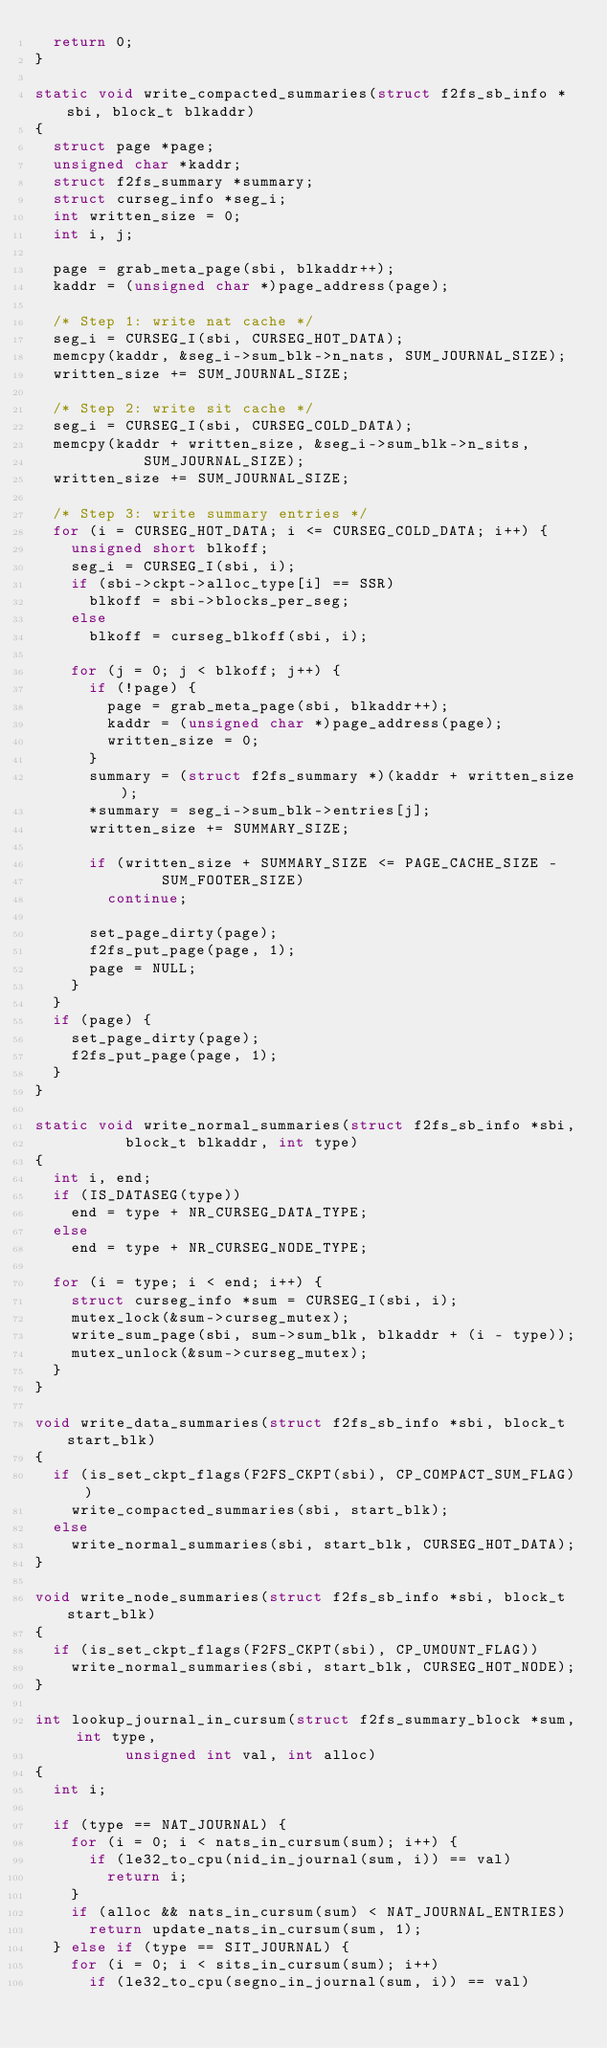<code> <loc_0><loc_0><loc_500><loc_500><_C_>	return 0;
}

static void write_compacted_summaries(struct f2fs_sb_info *sbi, block_t blkaddr)
{
	struct page *page;
	unsigned char *kaddr;
	struct f2fs_summary *summary;
	struct curseg_info *seg_i;
	int written_size = 0;
	int i, j;

	page = grab_meta_page(sbi, blkaddr++);
	kaddr = (unsigned char *)page_address(page);

	/* Step 1: write nat cache */
	seg_i = CURSEG_I(sbi, CURSEG_HOT_DATA);
	memcpy(kaddr, &seg_i->sum_blk->n_nats, SUM_JOURNAL_SIZE);
	written_size += SUM_JOURNAL_SIZE;

	/* Step 2: write sit cache */
	seg_i = CURSEG_I(sbi, CURSEG_COLD_DATA);
	memcpy(kaddr + written_size, &seg_i->sum_blk->n_sits,
						SUM_JOURNAL_SIZE);
	written_size += SUM_JOURNAL_SIZE;

	/* Step 3: write summary entries */
	for (i = CURSEG_HOT_DATA; i <= CURSEG_COLD_DATA; i++) {
		unsigned short blkoff;
		seg_i = CURSEG_I(sbi, i);
		if (sbi->ckpt->alloc_type[i] == SSR)
			blkoff = sbi->blocks_per_seg;
		else
			blkoff = curseg_blkoff(sbi, i);

		for (j = 0; j < blkoff; j++) {
			if (!page) {
				page = grab_meta_page(sbi, blkaddr++);
				kaddr = (unsigned char *)page_address(page);
				written_size = 0;
			}
			summary = (struct f2fs_summary *)(kaddr + written_size);
			*summary = seg_i->sum_blk->entries[j];
			written_size += SUMMARY_SIZE;

			if (written_size + SUMMARY_SIZE <= PAGE_CACHE_SIZE -
							SUM_FOOTER_SIZE)
				continue;

			set_page_dirty(page);
			f2fs_put_page(page, 1);
			page = NULL;
		}
	}
	if (page) {
		set_page_dirty(page);
		f2fs_put_page(page, 1);
	}
}

static void write_normal_summaries(struct f2fs_sb_info *sbi,
					block_t blkaddr, int type)
{
	int i, end;
	if (IS_DATASEG(type))
		end = type + NR_CURSEG_DATA_TYPE;
	else
		end = type + NR_CURSEG_NODE_TYPE;

	for (i = type; i < end; i++) {
		struct curseg_info *sum = CURSEG_I(sbi, i);
		mutex_lock(&sum->curseg_mutex);
		write_sum_page(sbi, sum->sum_blk, blkaddr + (i - type));
		mutex_unlock(&sum->curseg_mutex);
	}
}

void write_data_summaries(struct f2fs_sb_info *sbi, block_t start_blk)
{
	if (is_set_ckpt_flags(F2FS_CKPT(sbi), CP_COMPACT_SUM_FLAG))
		write_compacted_summaries(sbi, start_blk);
	else
		write_normal_summaries(sbi, start_blk, CURSEG_HOT_DATA);
}

void write_node_summaries(struct f2fs_sb_info *sbi, block_t start_blk)
{
	if (is_set_ckpt_flags(F2FS_CKPT(sbi), CP_UMOUNT_FLAG))
		write_normal_summaries(sbi, start_blk, CURSEG_HOT_NODE);
}

int lookup_journal_in_cursum(struct f2fs_summary_block *sum, int type,
					unsigned int val, int alloc)
{
	int i;

	if (type == NAT_JOURNAL) {
		for (i = 0; i < nats_in_cursum(sum); i++) {
			if (le32_to_cpu(nid_in_journal(sum, i)) == val)
				return i;
		}
		if (alloc && nats_in_cursum(sum) < NAT_JOURNAL_ENTRIES)
			return update_nats_in_cursum(sum, 1);
	} else if (type == SIT_JOURNAL) {
		for (i = 0; i < sits_in_cursum(sum); i++)
			if (le32_to_cpu(segno_in_journal(sum, i)) == val)</code> 